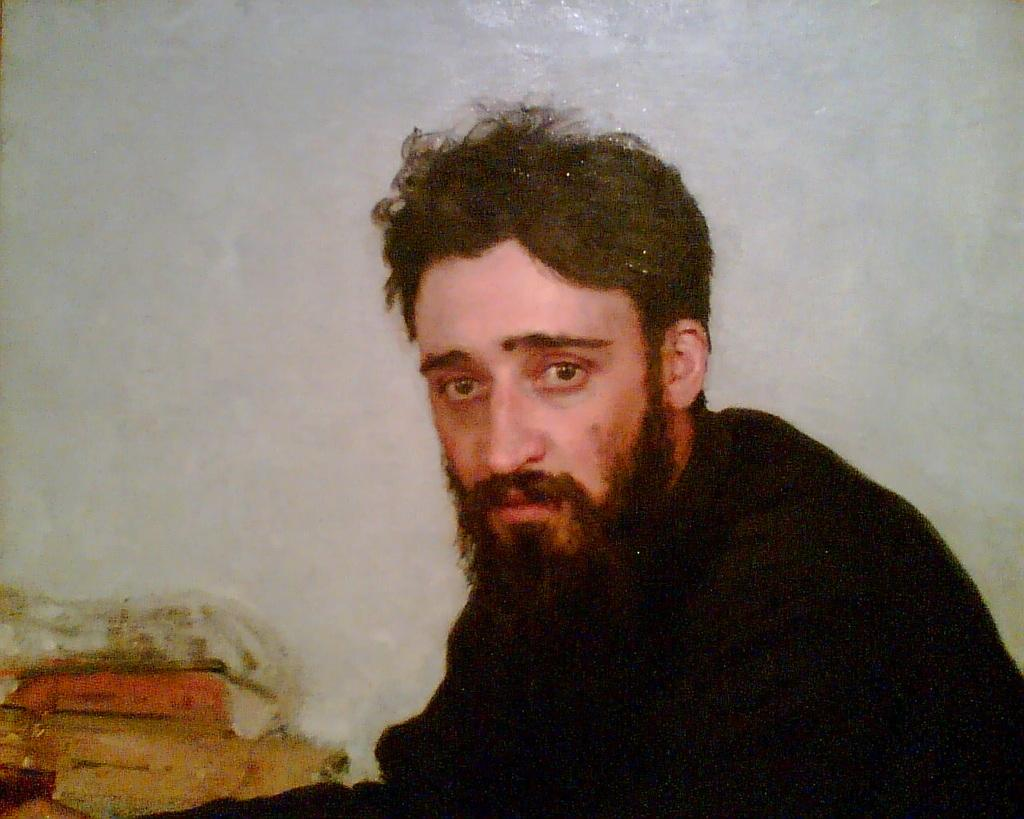Who or what is the main subject in the image? There is a person in the image. What color is the background of the image? The background of the image is white in color. How many layers of cake can be seen in the image? There is no cake present in the image. What type of support is the person using in the image? There is no visible support being used by the person in the image. 